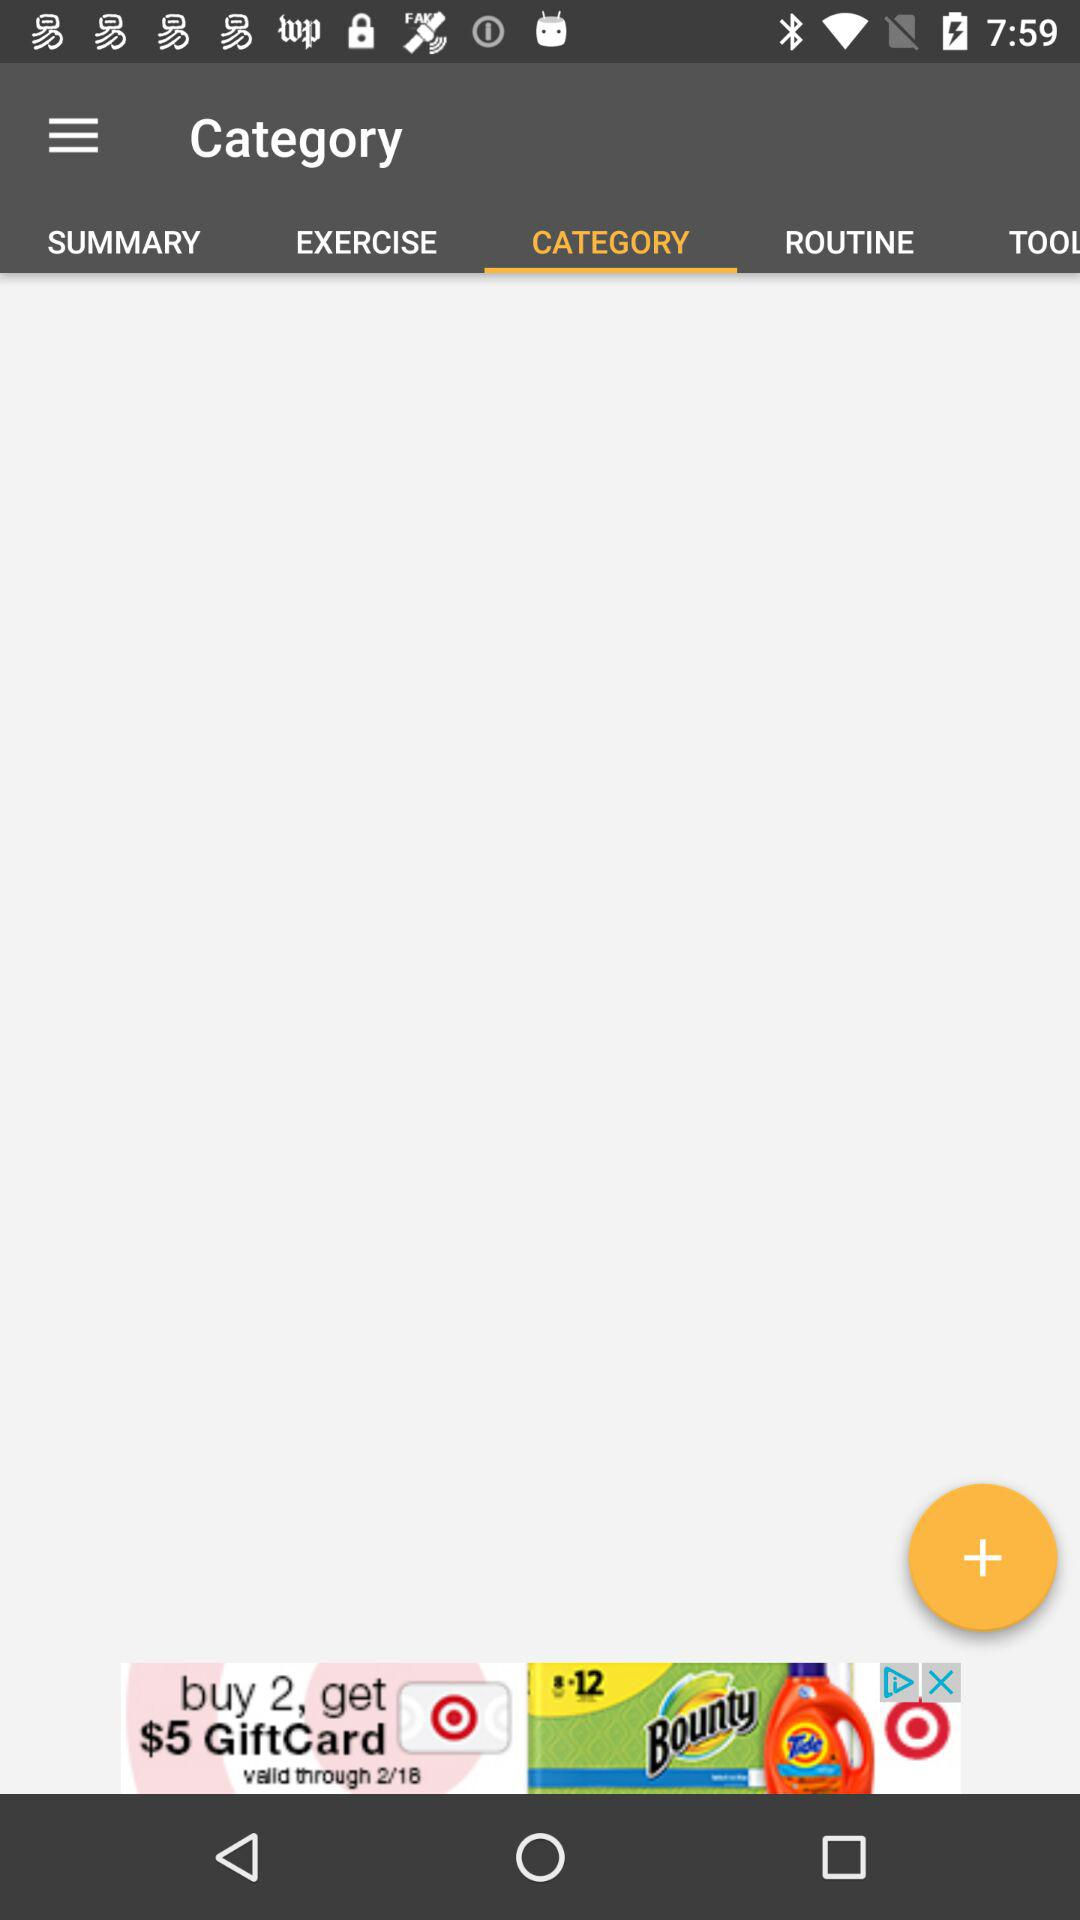Which is the selected tab? The selected tab is "CATEGORY". 